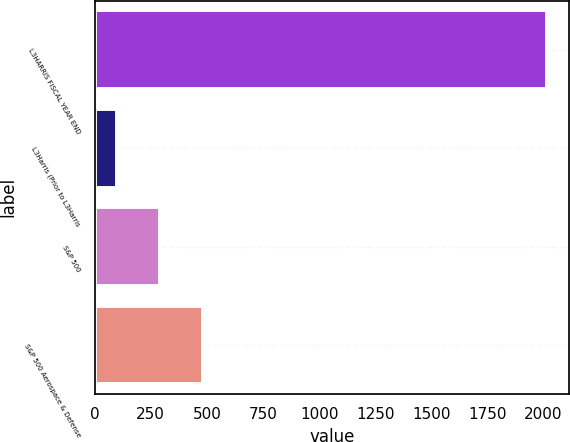Convert chart to OTSL. <chart><loc_0><loc_0><loc_500><loc_500><bar_chart><fcel>L3HARRIS FISCAL YEAR END<fcel>L3Harris (Prior to L3Harris<fcel>S&P 500<fcel>S&P 500 Aerospace & Defense<nl><fcel>2014<fcel>100<fcel>291.4<fcel>482.8<nl></chart> 